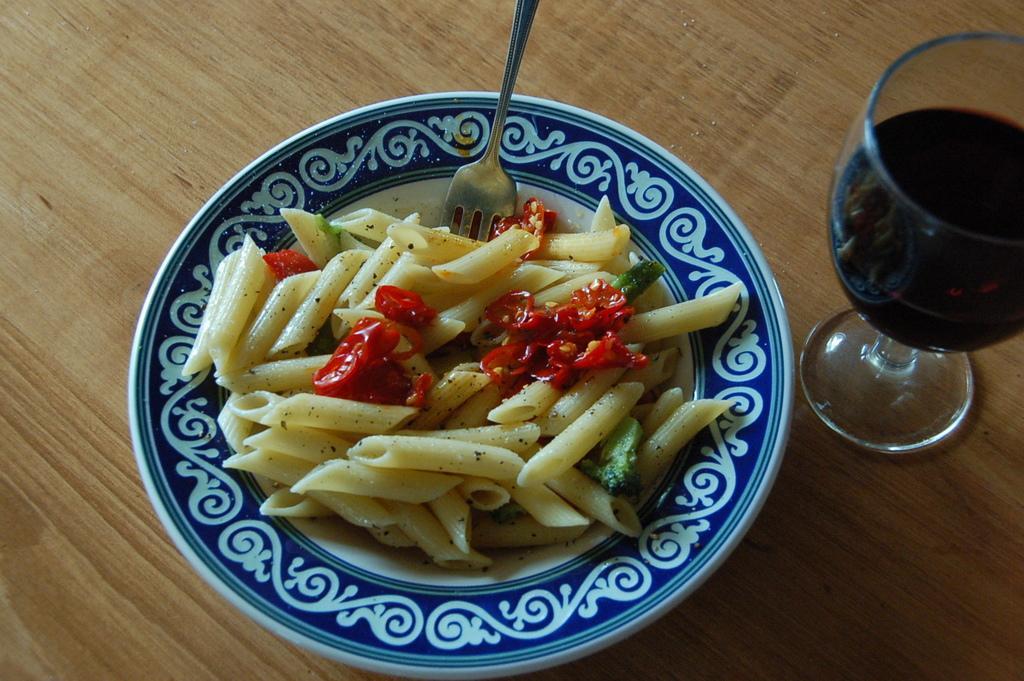In one or two sentences, can you explain what this image depicts? This picture shows pasta with some veggies in the plate and we see a fork and a glass with some liquid in it and and we see a table. 